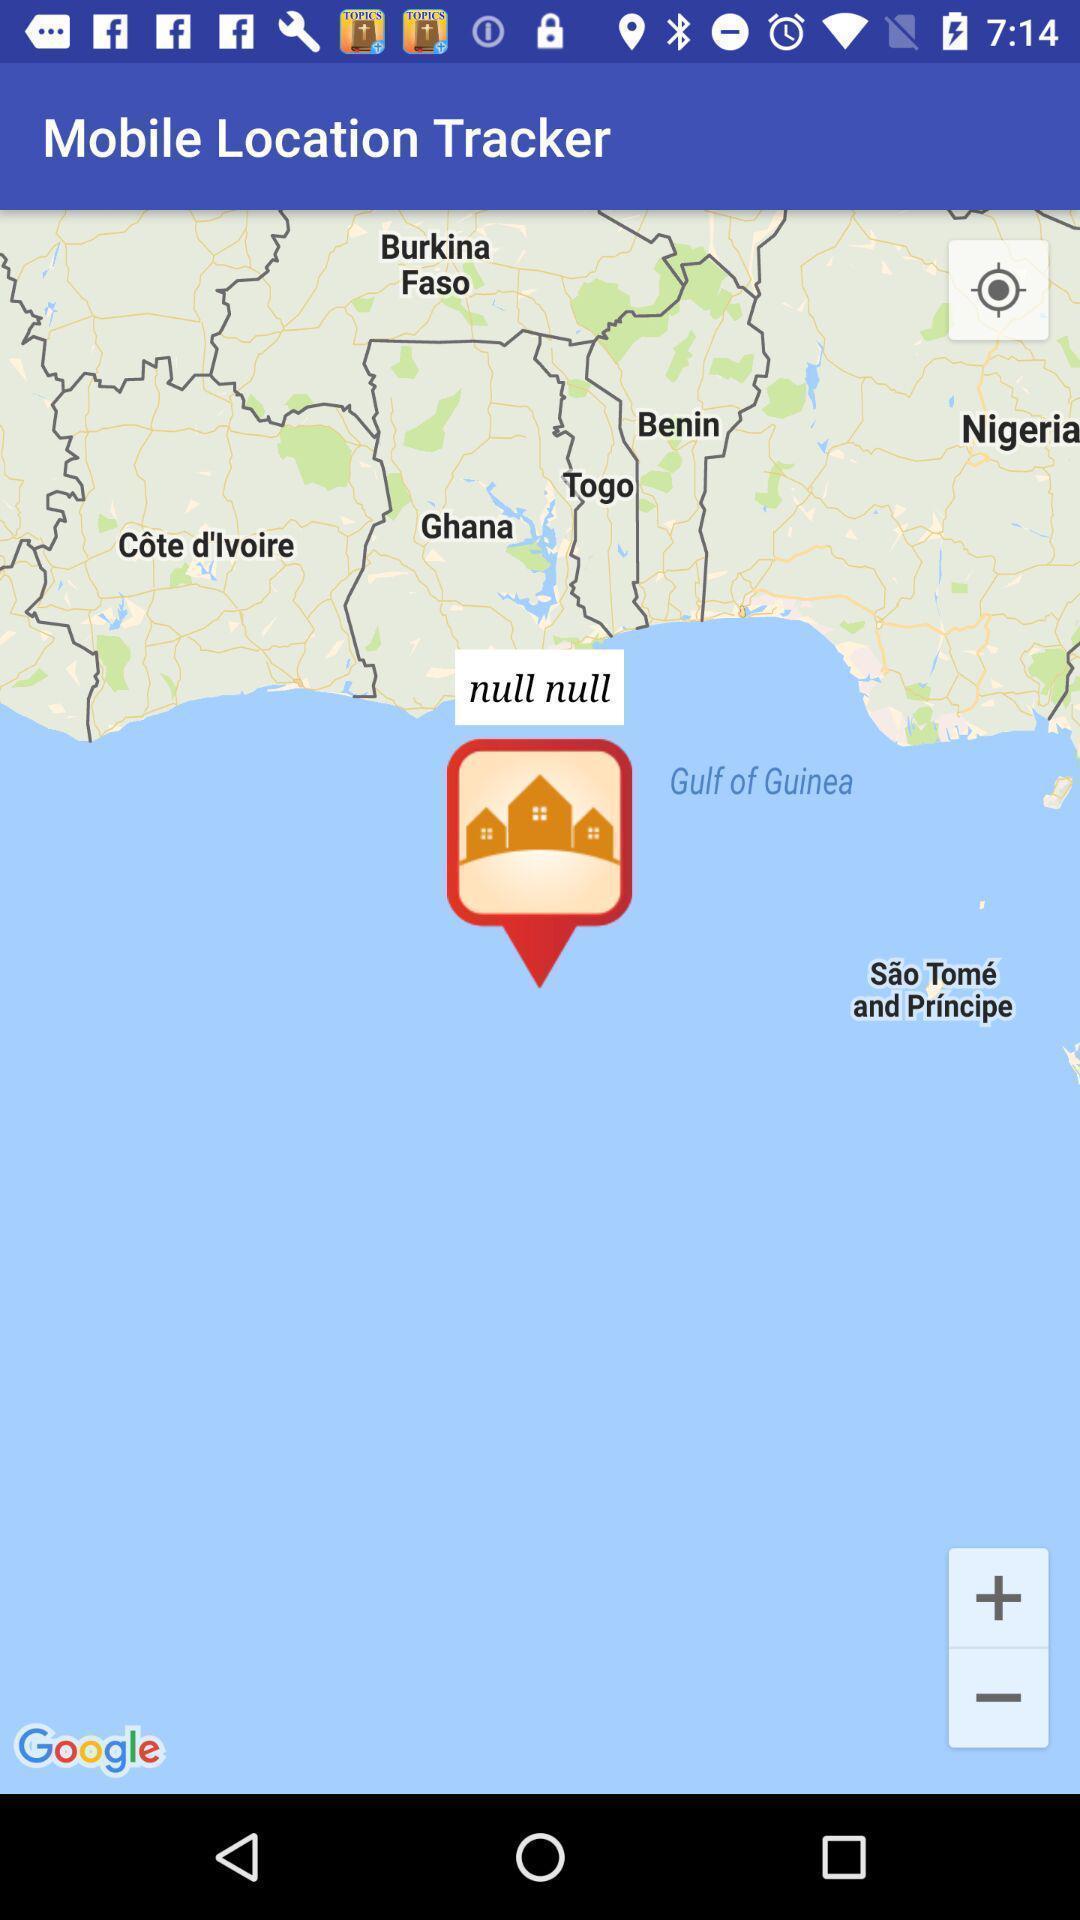What details can you identify in this image? Page displays different locations in a location tracking app. 